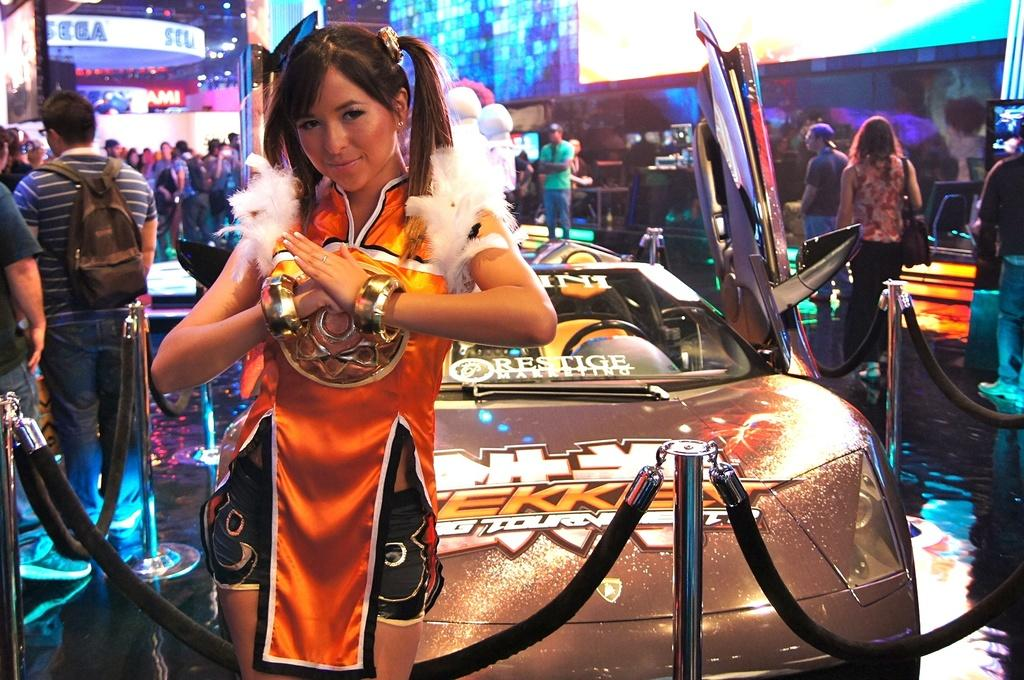Who is the main subject in the image? There is a woman in the image. What is the woman wearing? The woman is wearing an orange dress. What is the woman standing in front of? The woman is standing in front of a car. What are the other people in the image doing? There are many people walking in the image, on either side and in the background. Can you see any wounds on the woman in the image? There is no indication of any wounds on the woman in the image. What type of drawer is visible in the image? There is no drawer present in the image. 